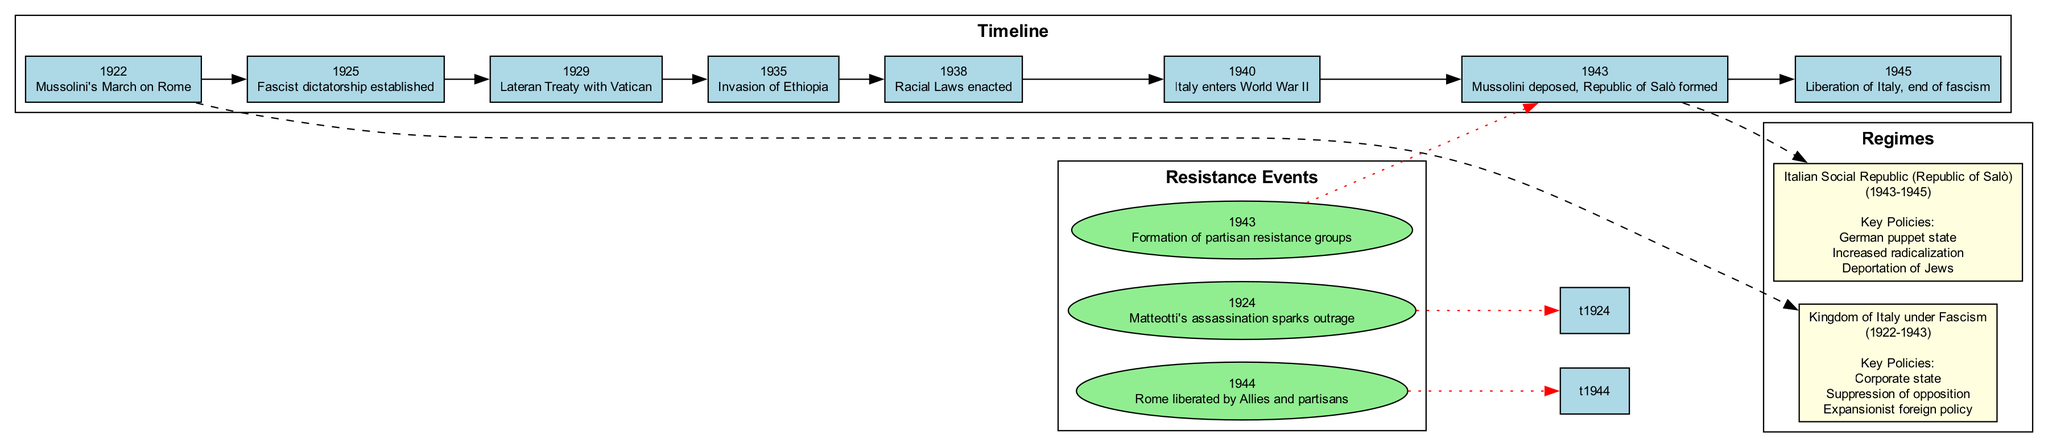What event marks the beginning of Mussolini's rule? The diagram shows "Mussolini's March on Rome" in 1922 as the first event in the timeline.
Answer: Mussolini's March on Rome What year did the Racial Laws get enacted? According to the timeline, the Racial Laws were enacted in 1938, which is clearly indicated in the diagram.
Answer: 1938 What key policy is associated with the Kingdom of Italy under Fascism? The diagram lists "Corporate state" as a key policy under the "Kingdom of Italy under Fascism," found in the section about regimes.
Answer: Corporate state How many resistance events are listed in the diagram? By counting the nodes labeled "Resistance Events," we see there are three resistance events indicated in the diagram.
Answer: 3 What is the relationship between the event of Mussolini's deposition and the formation of the Republic of Salò? The diagram shows an edge connecting "Mussolini deposed" in 1943 to the "Italian Social Republic (Republic of Salò)" which was formed the same year, indicating a direct connection.
Answer: Direct connection Which event correlates with the liberation of Rome? The diagram shows "Rome liberated by Allies and partisans" in 1944, connecting this resistance event to the timeline.
Answer: Rome liberated by Allies and partisans What regime was in place during the invasion of Ethiopia? The timeline indicates that during the year 1935, the regime was still the "Kingdom of Italy under Fascism" as shown in the diagram.
Answer: Kingdom of Italy under Fascism What policy indicates the increased radicalization under the Republic of Salò? The key policy "Increased radicalization" is directly mentioned in the policies associated with "Italian Social Republic (Republic of Salò)" within the diagram.
Answer: Increased radicalization How does the diagram visually represent the timeline's progression? The diagram uses identified edges to illustrate the timeline's flow, creating a clear linear path from one event to the next.
Answer: Linear path 